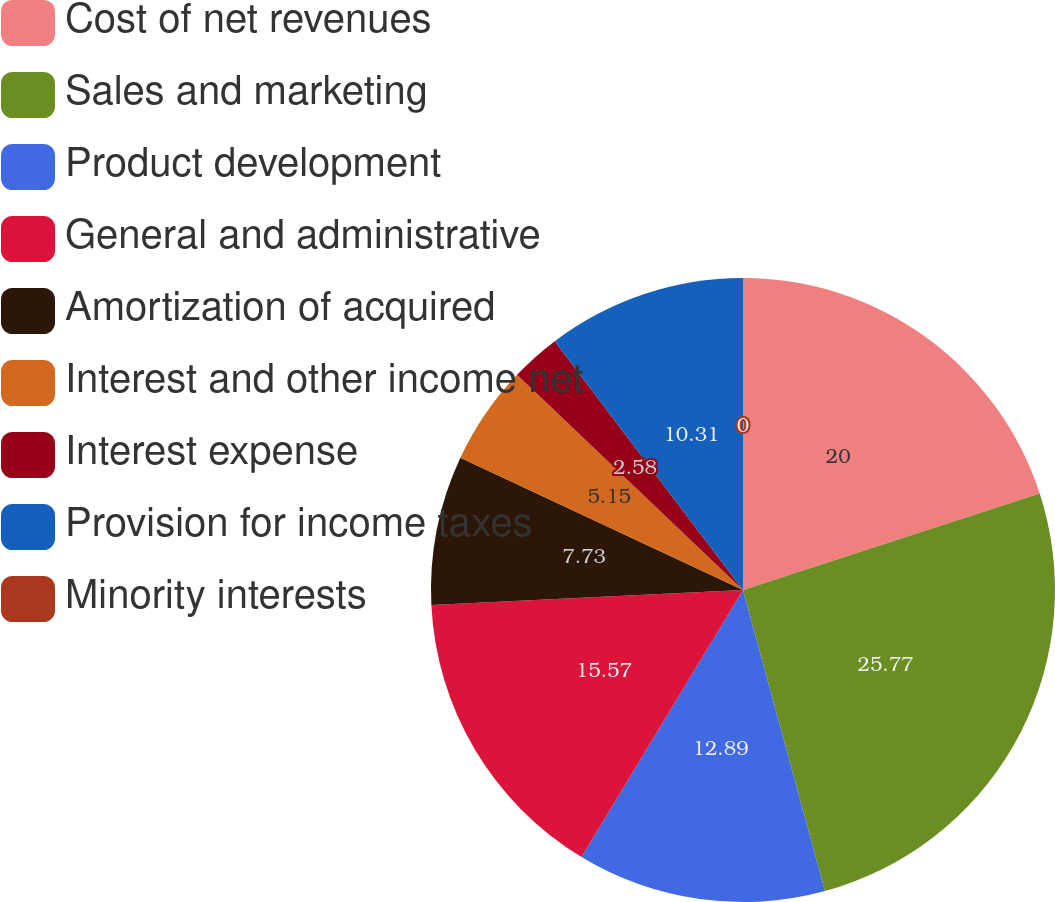Convert chart. <chart><loc_0><loc_0><loc_500><loc_500><pie_chart><fcel>Cost of net revenues<fcel>Sales and marketing<fcel>Product development<fcel>General and administrative<fcel>Amortization of acquired<fcel>Interest and other income net<fcel>Interest expense<fcel>Provision for income taxes<fcel>Minority interests<nl><fcel>20.0%<fcel>25.77%<fcel>12.89%<fcel>15.57%<fcel>7.73%<fcel>5.15%<fcel>2.58%<fcel>10.31%<fcel>0.0%<nl></chart> 